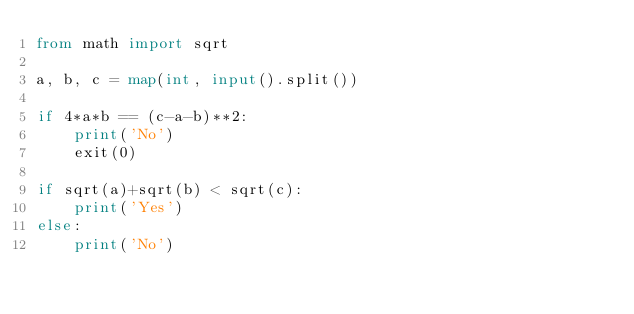Convert code to text. <code><loc_0><loc_0><loc_500><loc_500><_Python_>from math import sqrt

a, b, c = map(int, input().split())

if 4*a*b == (c-a-b)**2:
    print('No')
    exit(0)

if sqrt(a)+sqrt(b) < sqrt(c):
    print('Yes')
else:
    print('No')</code> 